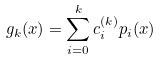Convert formula to latex. <formula><loc_0><loc_0><loc_500><loc_500>g _ { k } ( x ) = \sum _ { i = 0 } ^ { k } c ^ { ( k ) } _ { i } p _ { i } ( x )</formula> 